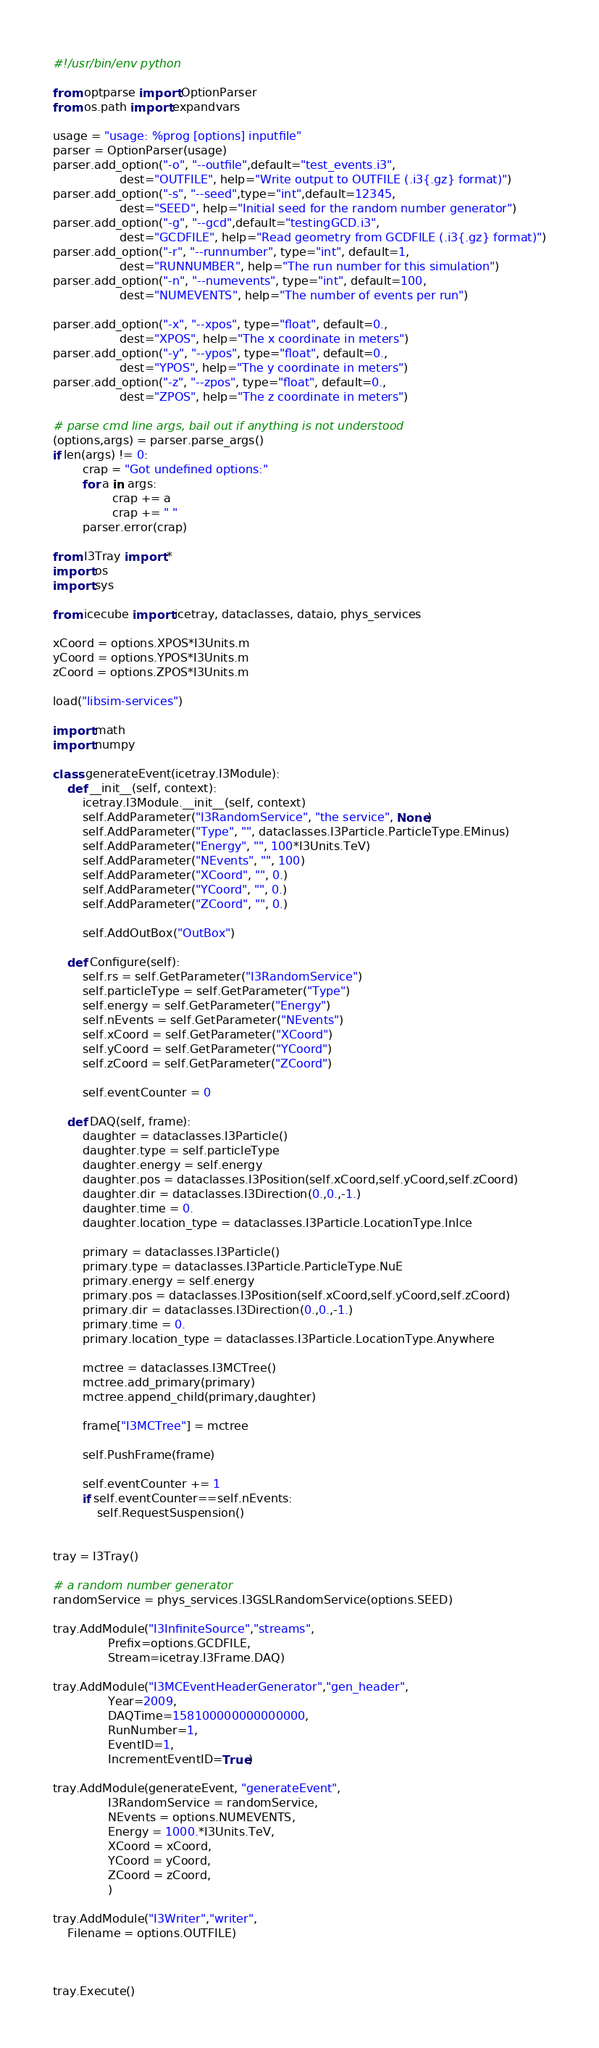<code> <loc_0><loc_0><loc_500><loc_500><_Python_>#!/usr/bin/env python

from optparse import OptionParser
from os.path import expandvars

usage = "usage: %prog [options] inputfile"
parser = OptionParser(usage)
parser.add_option("-o", "--outfile",default="test_events.i3",
                  dest="OUTFILE", help="Write output to OUTFILE (.i3{.gz} format)")
parser.add_option("-s", "--seed",type="int",default=12345,
                  dest="SEED", help="Initial seed for the random number generator")
parser.add_option("-g", "--gcd",default="testingGCD.i3",
                  dest="GCDFILE", help="Read geometry from GCDFILE (.i3{.gz} format)")
parser.add_option("-r", "--runnumber", type="int", default=1,
                  dest="RUNNUMBER", help="The run number for this simulation")
parser.add_option("-n", "--numevents", type="int", default=100,
                  dest="NUMEVENTS", help="The number of events per run")

parser.add_option("-x", "--xpos", type="float", default=0.,
                  dest="XPOS", help="The x coordinate in meters")
parser.add_option("-y", "--ypos", type="float", default=0.,
                  dest="YPOS", help="The y coordinate in meters")
parser.add_option("-z", "--zpos", type="float", default=0.,
                  dest="ZPOS", help="The z coordinate in meters")

# parse cmd line args, bail out if anything is not understood
(options,args) = parser.parse_args()
if len(args) != 0:
        crap = "Got undefined options:"
        for a in args:
                crap += a
                crap += " "
        parser.error(crap)

from I3Tray import *
import os
import sys

from icecube import icetray, dataclasses, dataio, phys_services

xCoord = options.XPOS*I3Units.m
yCoord = options.YPOS*I3Units.m
zCoord = options.ZPOS*I3Units.m

load("libsim-services")

import math
import numpy

class generateEvent(icetray.I3Module):
    def __init__(self, context):
        icetray.I3Module.__init__(self, context)
        self.AddParameter("I3RandomService", "the service", None)
        self.AddParameter("Type", "", dataclasses.I3Particle.ParticleType.EMinus)
        self.AddParameter("Energy", "", 100*I3Units.TeV)
        self.AddParameter("NEvents", "", 100)
        self.AddParameter("XCoord", "", 0.)
        self.AddParameter("YCoord", "", 0.)
        self.AddParameter("ZCoord", "", 0.)

        self.AddOutBox("OutBox")        

    def Configure(self):
        self.rs = self.GetParameter("I3RandomService")
        self.particleType = self.GetParameter("Type")
        self.energy = self.GetParameter("Energy")
        self.nEvents = self.GetParameter("NEvents")
        self.xCoord = self.GetParameter("XCoord")
        self.yCoord = self.GetParameter("YCoord")
        self.zCoord = self.GetParameter("ZCoord")
        
        self.eventCounter = 0

    def DAQ(self, frame):
        daughter = dataclasses.I3Particle()
        daughter.type = self.particleType
        daughter.energy = self.energy
        daughter.pos = dataclasses.I3Position(self.xCoord,self.yCoord,self.zCoord)
        daughter.dir = dataclasses.I3Direction(0.,0.,-1.)
        daughter.time = 0.
        daughter.location_type = dataclasses.I3Particle.LocationType.InIce

        primary = dataclasses.I3Particle()
        primary.type = dataclasses.I3Particle.ParticleType.NuE
        primary.energy = self.energy
        primary.pos = dataclasses.I3Position(self.xCoord,self.yCoord,self.zCoord)
        primary.dir = dataclasses.I3Direction(0.,0.,-1.)
        primary.time = 0.
        primary.location_type = dataclasses.I3Particle.LocationType.Anywhere

        mctree = dataclasses.I3MCTree()
        mctree.add_primary(primary)
        mctree.append_child(primary,daughter)

        frame["I3MCTree"] = mctree

        self.PushFrame(frame)

        self.eventCounter += 1
        if self.eventCounter==self.nEvents:
            self.RequestSuspension()


tray = I3Tray()

# a random number generator
randomService = phys_services.I3GSLRandomService(options.SEED)

tray.AddModule("I3InfiniteSource","streams",
               Prefix=options.GCDFILE,
               Stream=icetray.I3Frame.DAQ)

tray.AddModule("I3MCEventHeaderGenerator","gen_header",
               Year=2009,
               DAQTime=158100000000000000,
               RunNumber=1,
               EventID=1,
               IncrementEventID=True)

tray.AddModule(generateEvent, "generateEvent",
               I3RandomService = randomService,
               NEvents = options.NUMEVENTS,
               Energy = 1000.*I3Units.TeV,
               XCoord = xCoord,
               YCoord = yCoord,
               ZCoord = zCoord,
               )

tray.AddModule("I3Writer","writer",
    Filename = options.OUTFILE)



tray.Execute()




</code> 